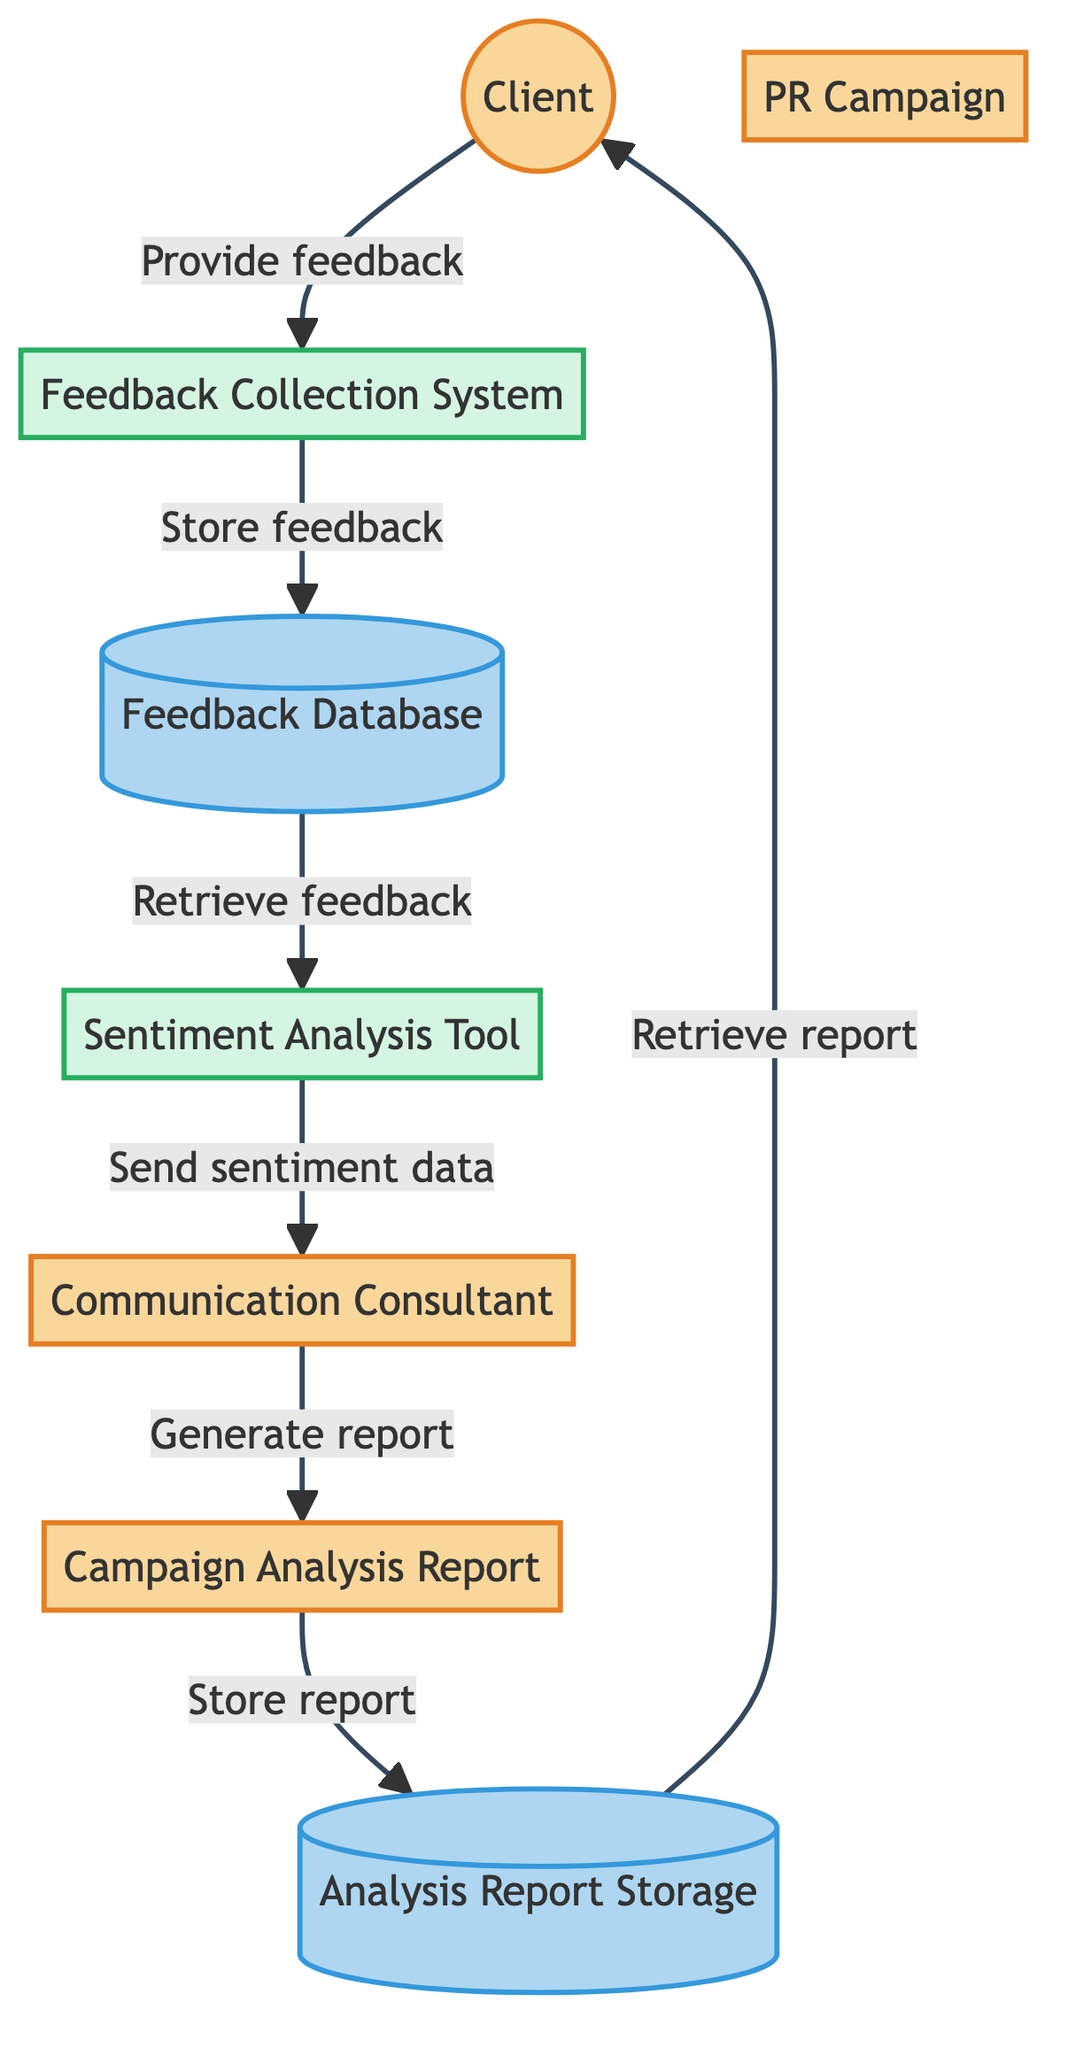What is the source of feedback in the diagram? The source of feedback is the "Client," who provides their opinions on the PR campaign. This is clearly indicated in the data flow from the "Client" to the "Feedback Collection System."
Answer: Client Which entity represents the tool used for sentiment analysis? The entity that represents the tool used for sentiment analysis is labeled "Sentiment Analysis Tool." This is derived from the specific description provided for the node within the diagram.
Answer: Sentiment Analysis Tool How many data stores are present in the diagram? There are two data stores present in the diagram: "Feedback Database" and "Analysis Report Storage." This can be counted directly from the data stores depicted in the diagram.
Answer: Two What data flow immediately follows the collection of feedback? The data flow that follows the collection of feedback is "Send Raw Feedback," where raw feedback data is sent from the "Feedback Collection System" to the "Sentiment Analysis Tool." This is indicated by the directed arrow in the diagram.
Answer: Send Raw Feedback What does the Communication Consultant generate after interpreting sentiment data? The Communication Consultant generates the "Campaign Analysis Report" after interpreting the sentiment data. This is shown by the data flow that connects the "Communication Consultant" to the "Campaign Analysis Report."
Answer: Campaign Analysis Report What is the final destination of the analysis report? The final destination of the analysis report is the "Client." This is shown in the diagram where the "Campaign Analysis Report" is delivered to the "Client."
Answer: Client Which process involves the interpretation of sentiment data? The process that involves the interpretation of sentiment data is labeled "Interpret Sentiment Data." It is one of the steps connected to the Communication Consultant in the diagram.
Answer: Interpret Sentiment Data What is the purpose of the Feedback Collection System? The purpose of the Feedback Collection System is to collect feedback from clients regarding the PR campaign. This is reflected in its description within the diagram.
Answer: To collect feedback What is stored in the Feedback Database? The Feedback Database is used to store collected client feedback. This function is noted in the description associated with the data store in the diagram.
Answer: Collected client feedback 